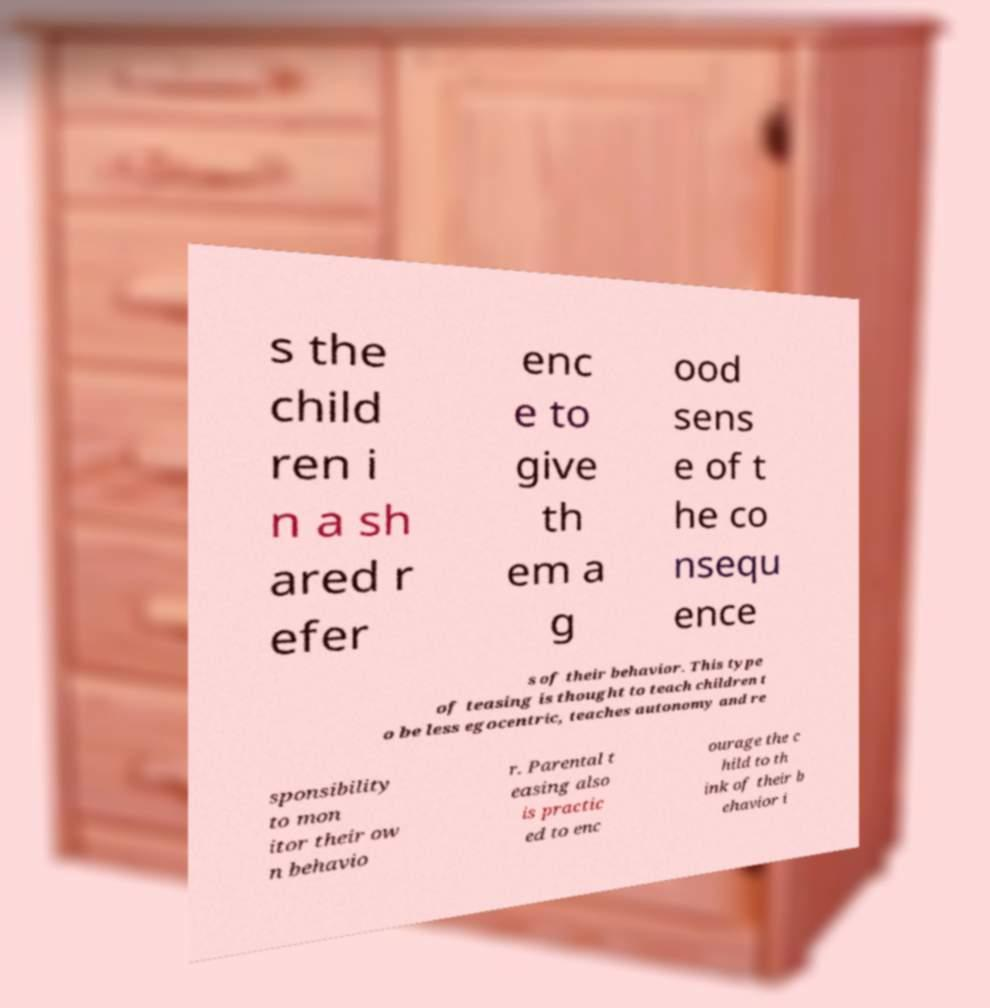There's text embedded in this image that I need extracted. Can you transcribe it verbatim? s the child ren i n a sh ared r efer enc e to give th em a g ood sens e of t he co nsequ ence s of their behavior. This type of teasing is thought to teach children t o be less egocentric, teaches autonomy and re sponsibility to mon itor their ow n behavio r. Parental t easing also is practic ed to enc ourage the c hild to th ink of their b ehavior i 